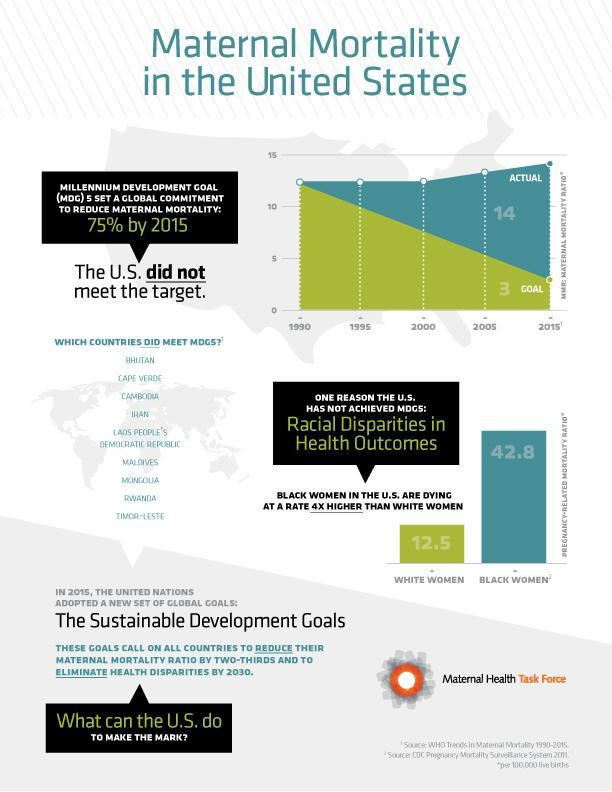What is difference in percentage of deaths between the Black and White Women ?
Answer the question with a short phrase. 30.3 How many countries met the Millennium Development Goal to reduce maternal mortality ? 9 